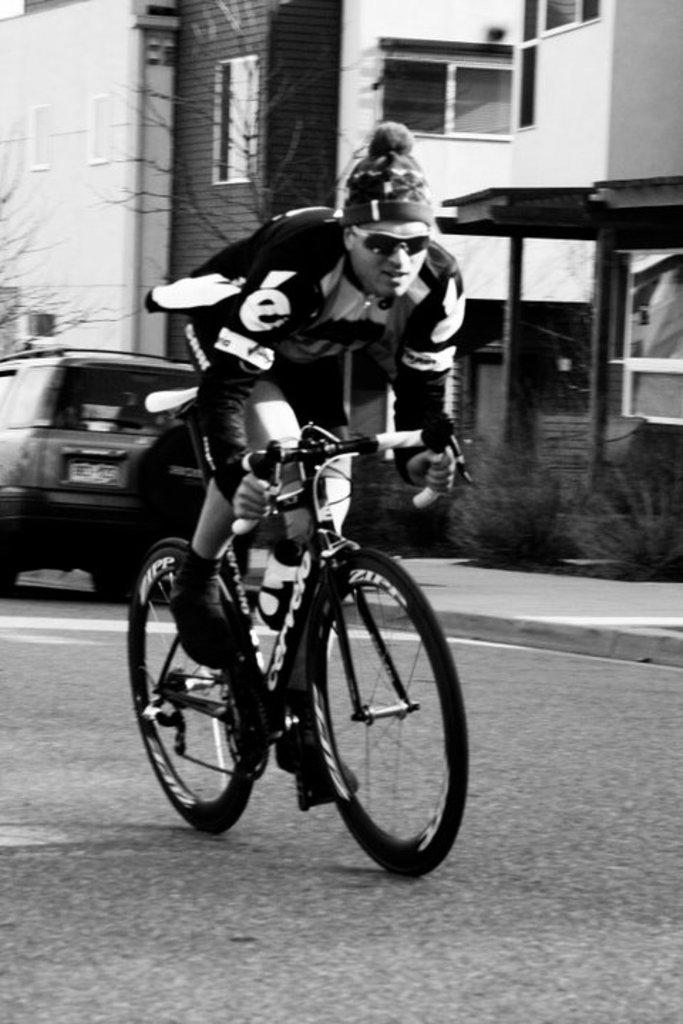What is the man in the image doing? The man is on a cycle in the image. Where is the man located in the image? The man is on a path in the image. What can be seen in the background of the image? There are plants, trees, a car, and buildings in the background of the image. What type of prison can be seen in the image? There is no prison present in the image. The image features a man on a cycle, a path, and various elements in the background, but no prison is visible. 